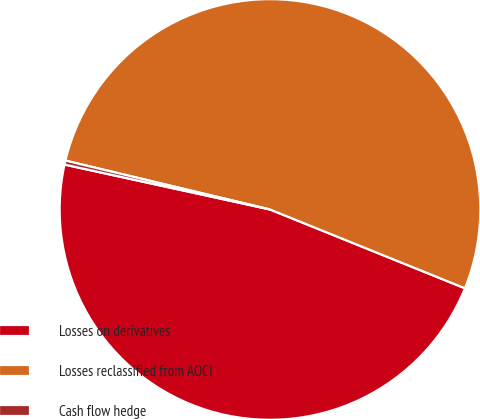Convert chart. <chart><loc_0><loc_0><loc_500><loc_500><pie_chart><fcel>Losses on derivatives<fcel>Losses reclassified from AOCI<fcel>Cash flow hedge<nl><fcel>47.31%<fcel>52.38%<fcel>0.31%<nl></chart> 